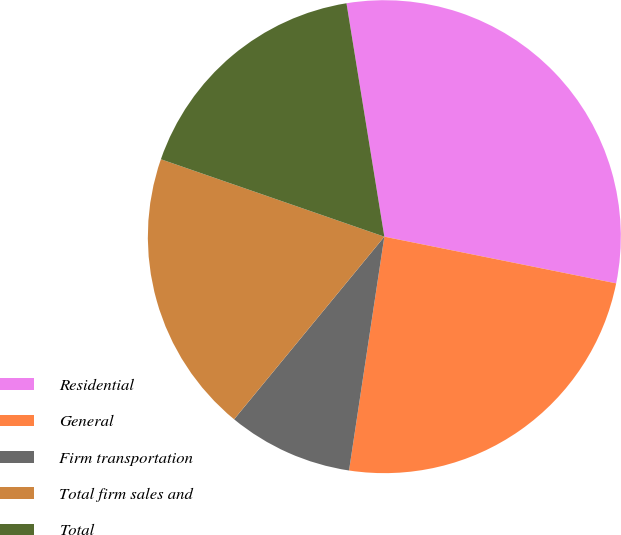<chart> <loc_0><loc_0><loc_500><loc_500><pie_chart><fcel>Residential<fcel>General<fcel>Firm transportation<fcel>Total firm sales and<fcel>Total<nl><fcel>30.72%<fcel>24.22%<fcel>8.57%<fcel>19.35%<fcel>17.13%<nl></chart> 